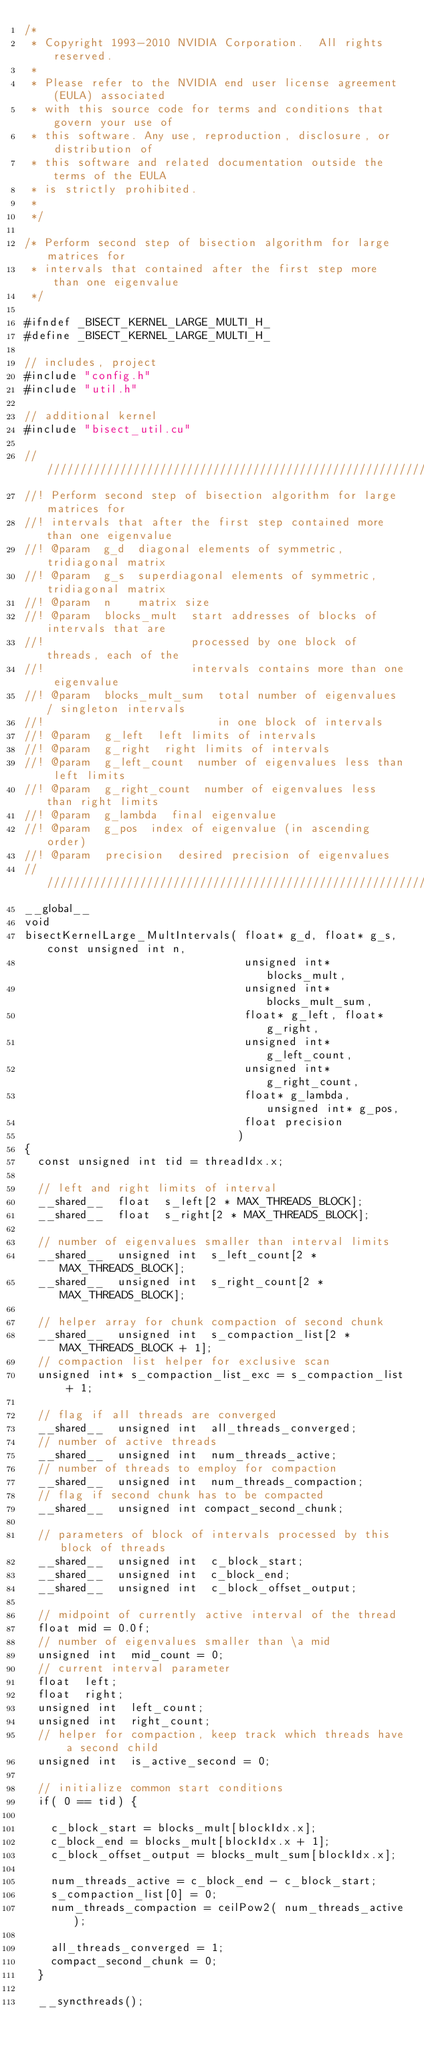<code> <loc_0><loc_0><loc_500><loc_500><_Cuda_>/*
 * Copyright 1993-2010 NVIDIA Corporation.  All rights reserved.
 *
 * Please refer to the NVIDIA end user license agreement (EULA) associated
 * with this source code for terms and conditions that govern your use of
 * this software. Any use, reproduction, disclosure, or distribution of
 * this software and related documentation outside the terms of the EULA
 * is strictly prohibited.
 *
 */

/* Perform second step of bisection algorithm for large matrices for
 * intervals that contained after the first step more than one eigenvalue
 */

#ifndef _BISECT_KERNEL_LARGE_MULTI_H_
#define _BISECT_KERNEL_LARGE_MULTI_H_

// includes, project
#include "config.h"
#include "util.h"

// additional kernel
#include "bisect_util.cu"

////////////////////////////////////////////////////////////////////////////////
//! Perform second step of bisection algorithm for large matrices for
//! intervals that after the first step contained more than one eigenvalue
//! @param  g_d  diagonal elements of symmetric, tridiagonal matrix
//! @param  g_s  superdiagonal elements of symmetric, tridiagonal matrix
//! @param  n    matrix size
//! @param  blocks_mult  start addresses of blocks of intervals that are 
//!                      processed by one block of threads, each of the 
//!                      intervals contains more than one eigenvalue
//! @param  blocks_mult_sum  total number of eigenvalues / singleton intervals
//!                          in one block of intervals
//! @param  g_left  left limits of intervals
//! @param  g_right  right limits of intervals
//! @param  g_left_count  number of eigenvalues less than left limits
//! @param  g_right_count  number of eigenvalues less than right limits
//! @param  g_lambda  final eigenvalue
//! @param  g_pos  index of eigenvalue (in ascending order)
//! @param  precision  desired precision of eigenvalues
////////////////////////////////////////////////////////////////////////////////
__global__
void
bisectKernelLarge_MultIntervals( float* g_d, float* g_s, const unsigned int n,
                                 unsigned int* blocks_mult,
                                 unsigned int* blocks_mult_sum,
                                 float* g_left, float* g_right, 
                                 unsigned int* g_left_count,
                                 unsigned int* g_right_count,
                                 float* g_lambda, unsigned int* g_pos,
                                 float precision
                                )
{
  const unsigned int tid = threadIdx.x;

  // left and right limits of interval
  __shared__  float  s_left[2 * MAX_THREADS_BLOCK];
  __shared__  float  s_right[2 * MAX_THREADS_BLOCK];

  // number of eigenvalues smaller than interval limits
  __shared__  unsigned int  s_left_count[2 * MAX_THREADS_BLOCK];
  __shared__  unsigned int  s_right_count[2 * MAX_THREADS_BLOCK];

  // helper array for chunk compaction of second chunk
  __shared__  unsigned int  s_compaction_list[2 * MAX_THREADS_BLOCK + 1];
  // compaction list helper for exclusive scan
  unsigned int* s_compaction_list_exc = s_compaction_list + 1;

  // flag if all threads are converged
  __shared__  unsigned int  all_threads_converged;
  // number of active threads
  __shared__  unsigned int  num_threads_active;
  // number of threads to employ for compaction
  __shared__  unsigned int  num_threads_compaction;
  // flag if second chunk has to be compacted
  __shared__  unsigned int compact_second_chunk;

  // parameters of block of intervals processed by this block of threads
  __shared__  unsigned int  c_block_start;
  __shared__  unsigned int  c_block_end;
  __shared__  unsigned int  c_block_offset_output;

  // midpoint of currently active interval of the thread
  float mid = 0.0f;
  // number of eigenvalues smaller than \a mid
  unsigned int  mid_count = 0;
  // current interval parameter
  float  left;
  float  right;
  unsigned int  left_count;
  unsigned int  right_count;
  // helper for compaction, keep track which threads have a second child
  unsigned int  is_active_second = 0;

  // initialize common start conditions
  if( 0 == tid) {

    c_block_start = blocks_mult[blockIdx.x];
    c_block_end = blocks_mult[blockIdx.x + 1];
    c_block_offset_output = blocks_mult_sum[blockIdx.x];

    num_threads_active = c_block_end - c_block_start;
    s_compaction_list[0] = 0;
    num_threads_compaction = ceilPow2( num_threads_active);

    all_threads_converged = 1;
    compact_second_chunk = 0;
  }

  __syncthreads();
</code> 